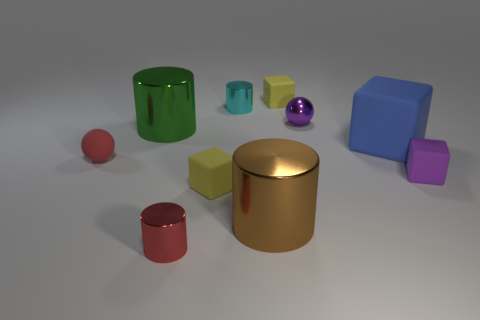There is a small cyan object; what shape is it?
Your answer should be compact. Cylinder. How many yellow things have the same shape as the red metallic object?
Your response must be concise. 0. Are there fewer brown objects behind the cyan cylinder than tiny objects in front of the big blue rubber cube?
Provide a short and direct response. Yes. How many tiny yellow blocks are left of the tiny rubber cube behind the big blue block?
Keep it short and to the point. 1. Is there a large red rubber object?
Provide a succinct answer. No. Are there any red objects made of the same material as the big blue object?
Provide a succinct answer. Yes. Is the number of tiny purple rubber objects that are to the right of the cyan cylinder greater than the number of tiny red shiny things that are right of the large blue rubber object?
Provide a succinct answer. Yes. Is the size of the green cylinder the same as the blue object?
Your answer should be very brief. Yes. There is a large object to the left of the yellow block that is to the left of the brown metal object; what is its color?
Your response must be concise. Green. The metallic sphere is what color?
Ensure brevity in your answer.  Purple. 